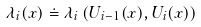Convert formula to latex. <formula><loc_0><loc_0><loc_500><loc_500>\lambda _ { i } ( x ) \doteq \lambda _ { i } \left ( U _ { i - 1 } ( x ) , U _ { i } ( x ) \right )</formula> 